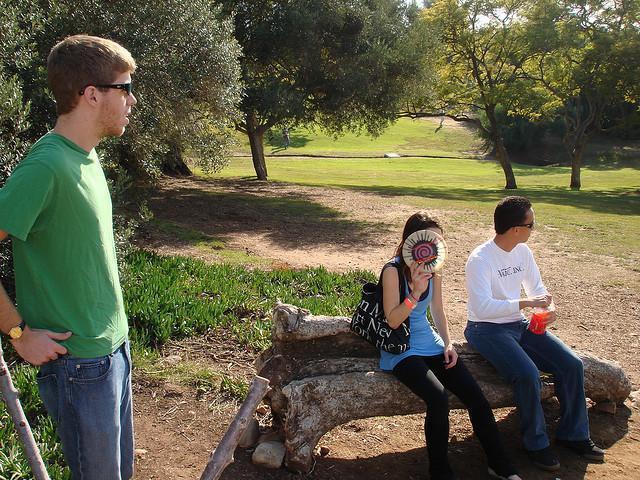Why is she holding up the item?
Pick the right solution, then justify: 'Answer: answer
Rationale: rationale.'
Options: Listening, throwing, afraid, camera shy. Answer: camera shy.
Rationale: Frisbees aren't used for covering a person's face. a photo was being taken and she probably doesn't like having her picture taken. 